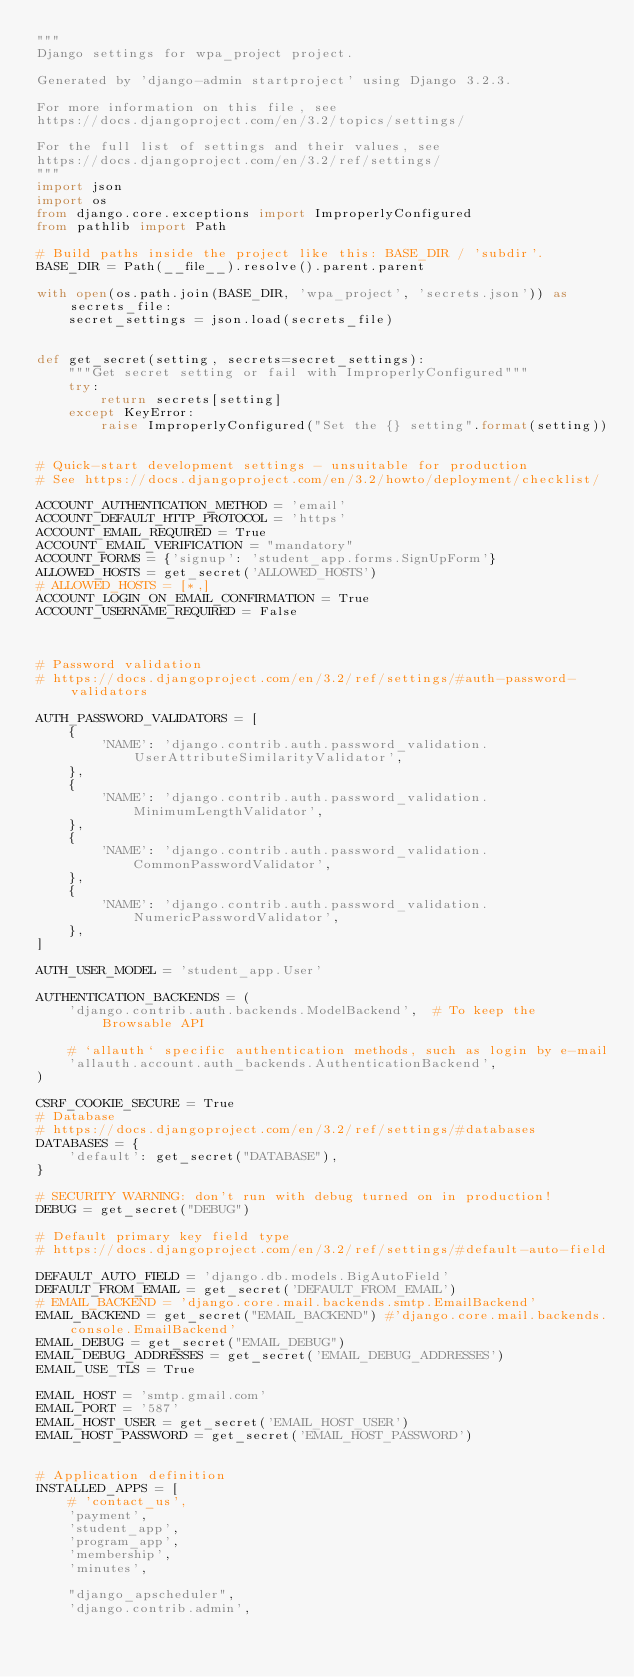<code> <loc_0><loc_0><loc_500><loc_500><_Python_>"""
Django settings for wpa_project project.

Generated by 'django-admin startproject' using Django 3.2.3.

For more information on this file, see
https://docs.djangoproject.com/en/3.2/topics/settings/

For the full list of settings and their values, see
https://docs.djangoproject.com/en/3.2/ref/settings/
"""
import json
import os
from django.core.exceptions import ImproperlyConfigured
from pathlib import Path

# Build paths inside the project like this: BASE_DIR / 'subdir'.
BASE_DIR = Path(__file__).resolve().parent.parent

with open(os.path.join(BASE_DIR, 'wpa_project', 'secrets.json')) as secrets_file:
    secret_settings = json.load(secrets_file)


def get_secret(setting, secrets=secret_settings):
    """Get secret setting or fail with ImproperlyConfigured"""
    try:
        return secrets[setting]
    except KeyError:
        raise ImproperlyConfigured("Set the {} setting".format(setting))


# Quick-start development settings - unsuitable for production
# See https://docs.djangoproject.com/en/3.2/howto/deployment/checklist/

ACCOUNT_AUTHENTICATION_METHOD = 'email'
ACCOUNT_DEFAULT_HTTP_PROTOCOL = 'https'
ACCOUNT_EMAIL_REQUIRED = True
ACCOUNT_EMAIL_VERIFICATION = "mandatory"
ACCOUNT_FORMS = {'signup': 'student_app.forms.SignUpForm'}
ALLOWED_HOSTS = get_secret('ALLOWED_HOSTS')
# ALLOWED_HOSTS = [*,]
ACCOUNT_LOGIN_ON_EMAIL_CONFIRMATION = True
ACCOUNT_USERNAME_REQUIRED = False



# Password validation
# https://docs.djangoproject.com/en/3.2/ref/settings/#auth-password-validators

AUTH_PASSWORD_VALIDATORS = [
    {
        'NAME': 'django.contrib.auth.password_validation.UserAttributeSimilarityValidator',
    },
    {
        'NAME': 'django.contrib.auth.password_validation.MinimumLengthValidator',
    },
    {
        'NAME': 'django.contrib.auth.password_validation.CommonPasswordValidator',
    },
    {
        'NAME': 'django.contrib.auth.password_validation.NumericPasswordValidator',
    },
]

AUTH_USER_MODEL = 'student_app.User'

AUTHENTICATION_BACKENDS = (
    'django.contrib.auth.backends.ModelBackend',  # To keep the Browsable API

    # `allauth` specific authentication methods, such as login by e-mail
    'allauth.account.auth_backends.AuthenticationBackend',
)

CSRF_COOKIE_SECURE = True
# Database
# https://docs.djangoproject.com/en/3.2/ref/settings/#databases
DATABASES = {
    'default': get_secret("DATABASE"),
}

# SECURITY WARNING: don't run with debug turned on in production!
DEBUG = get_secret("DEBUG")

# Default primary key field type
# https://docs.djangoproject.com/en/3.2/ref/settings/#default-auto-field

DEFAULT_AUTO_FIELD = 'django.db.models.BigAutoField'
DEFAULT_FROM_EMAIL = get_secret('DEFAULT_FROM_EMAIL')
# EMAIL_BACKEND = 'django.core.mail.backends.smtp.EmailBackend'
EMAIL_BACKEND = get_secret("EMAIL_BACKEND") #'django.core.mail.backends.console.EmailBackend'
EMAIL_DEBUG = get_secret("EMAIL_DEBUG")
EMAIL_DEBUG_ADDRESSES = get_secret('EMAIL_DEBUG_ADDRESSES')
EMAIL_USE_TLS = True

EMAIL_HOST = 'smtp.gmail.com'
EMAIL_PORT = '587'
EMAIL_HOST_USER = get_secret('EMAIL_HOST_USER')
EMAIL_HOST_PASSWORD = get_secret('EMAIL_HOST_PASSWORD')


# Application definition
INSTALLED_APPS = [
    # 'contact_us',
    'payment',
    'student_app',
    'program_app',
    'membership',
    'minutes',

    "django_apscheduler",
    'django.contrib.admin',</code> 